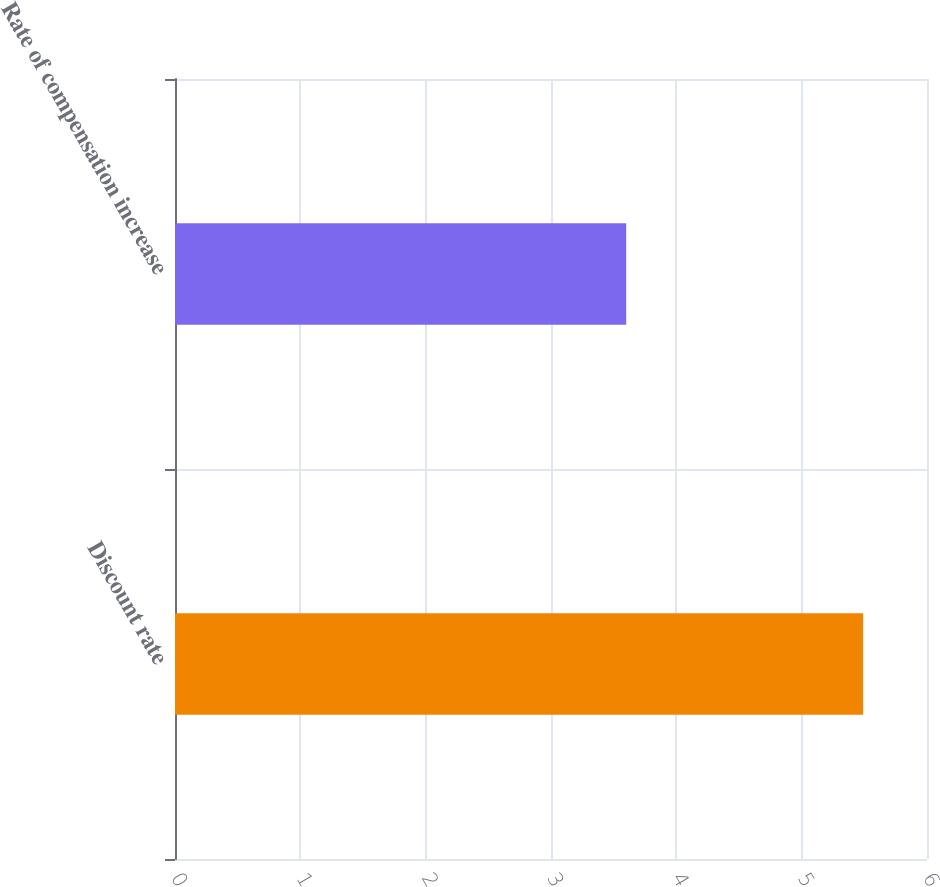<chart> <loc_0><loc_0><loc_500><loc_500><bar_chart><fcel>Discount rate<fcel>Rate of compensation increase<nl><fcel>5.49<fcel>3.6<nl></chart> 